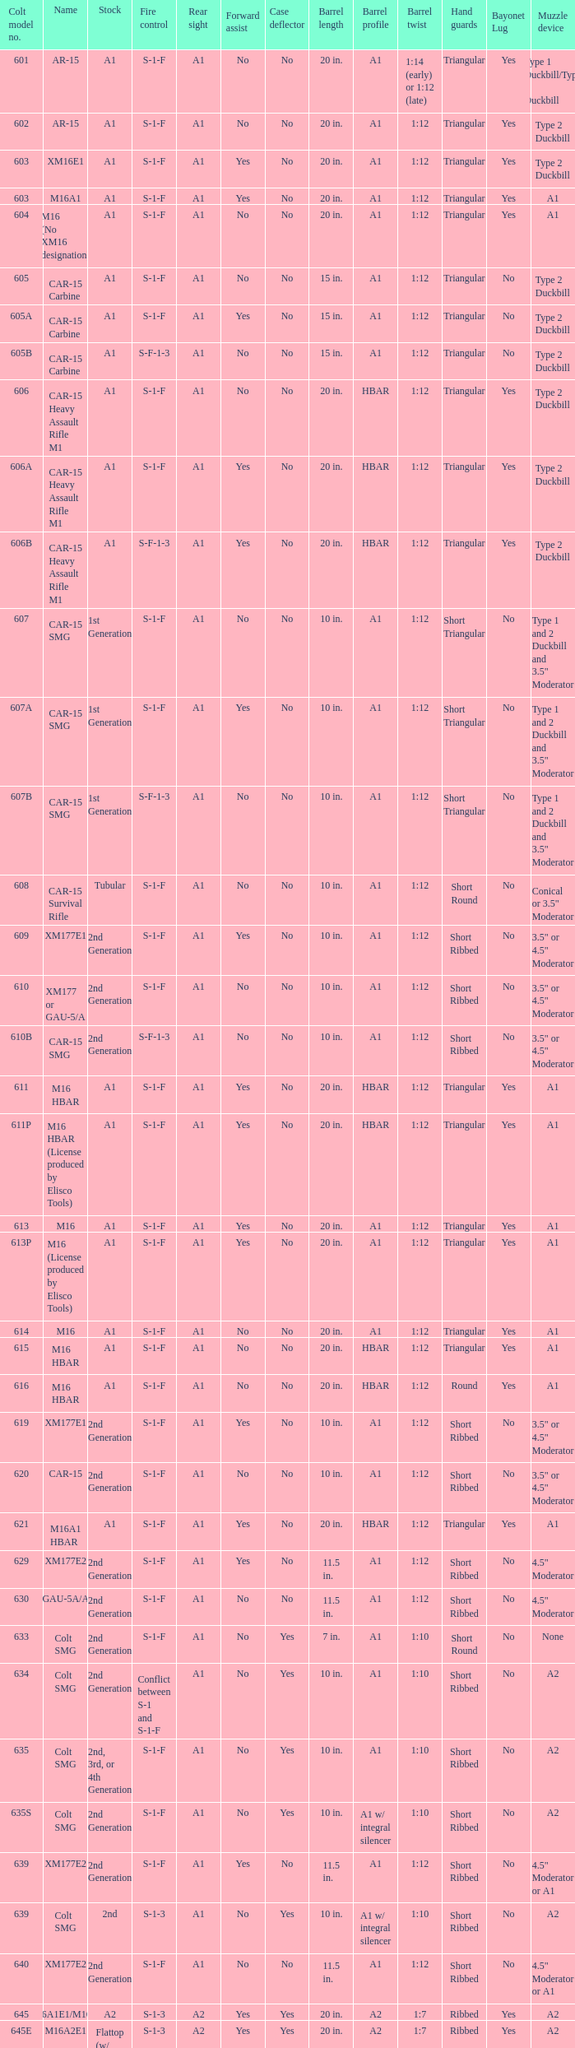What is the rear sight in the Cole model no. 735? A1 or A2. 